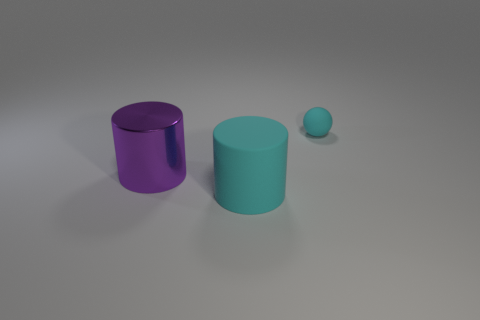What number of other things are there of the same size as the ball?
Offer a very short reply. 0. Is the color of the thing that is on the right side of the big cyan cylinder the same as the large matte object?
Offer a terse response. Yes. There is a object that is in front of the small cyan ball and behind the large cyan cylinder; what size is it?
Offer a very short reply. Large. How many small things are either spheres or brown cylinders?
Provide a succinct answer. 1. What shape is the cyan thing behind the big metal cylinder?
Offer a terse response. Sphere. What number of purple objects are there?
Provide a short and direct response. 1. Is the material of the tiny thing the same as the large cyan object?
Provide a succinct answer. Yes. Are there more purple things that are in front of the cyan matte cylinder than big green metal blocks?
Offer a very short reply. No. How many objects are either small gray matte cylinders or big things that are in front of the big purple thing?
Offer a very short reply. 1. Is the number of matte things behind the rubber cylinder greater than the number of purple shiny cylinders behind the purple shiny cylinder?
Provide a succinct answer. Yes. 